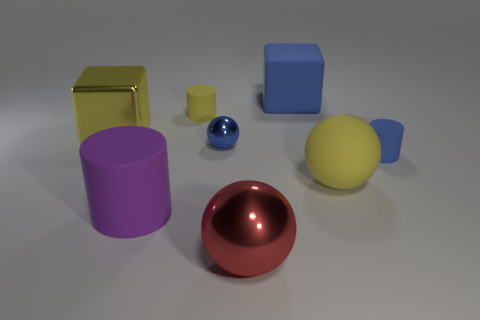The big rubber thing that is in front of the blue shiny ball and right of the small yellow object has what shape?
Provide a succinct answer. Sphere. What number of large gray matte objects are there?
Ensure brevity in your answer.  0. What is the shape of the big object that is the same color as the small shiny thing?
Offer a very short reply. Cube. What is the size of the blue object that is the same shape as the purple thing?
Ensure brevity in your answer.  Small. Is the shape of the large metal thing that is to the left of the red shiny thing the same as  the big red metal thing?
Keep it short and to the point. No. What color is the cylinder behind the blue metallic object?
Your answer should be compact. Yellow. What number of other things are there of the same size as the yellow cylinder?
Your response must be concise. 2. Is there any other thing that is the same shape as the large blue object?
Provide a short and direct response. Yes. Is the number of yellow rubber things behind the big yellow metallic thing the same as the number of small yellow matte cylinders?
Your response must be concise. Yes. How many other yellow spheres have the same material as the yellow sphere?
Your response must be concise. 0. 